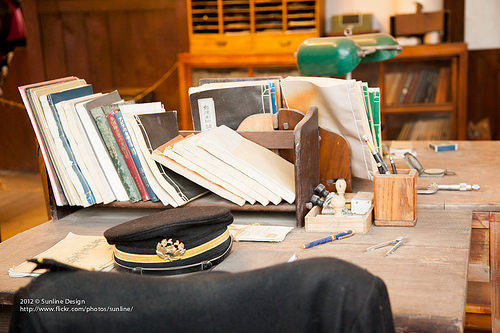<image>
Is the jacket in front of the hat? Yes. The jacket is positioned in front of the hat, appearing closer to the camera viewpoint. 